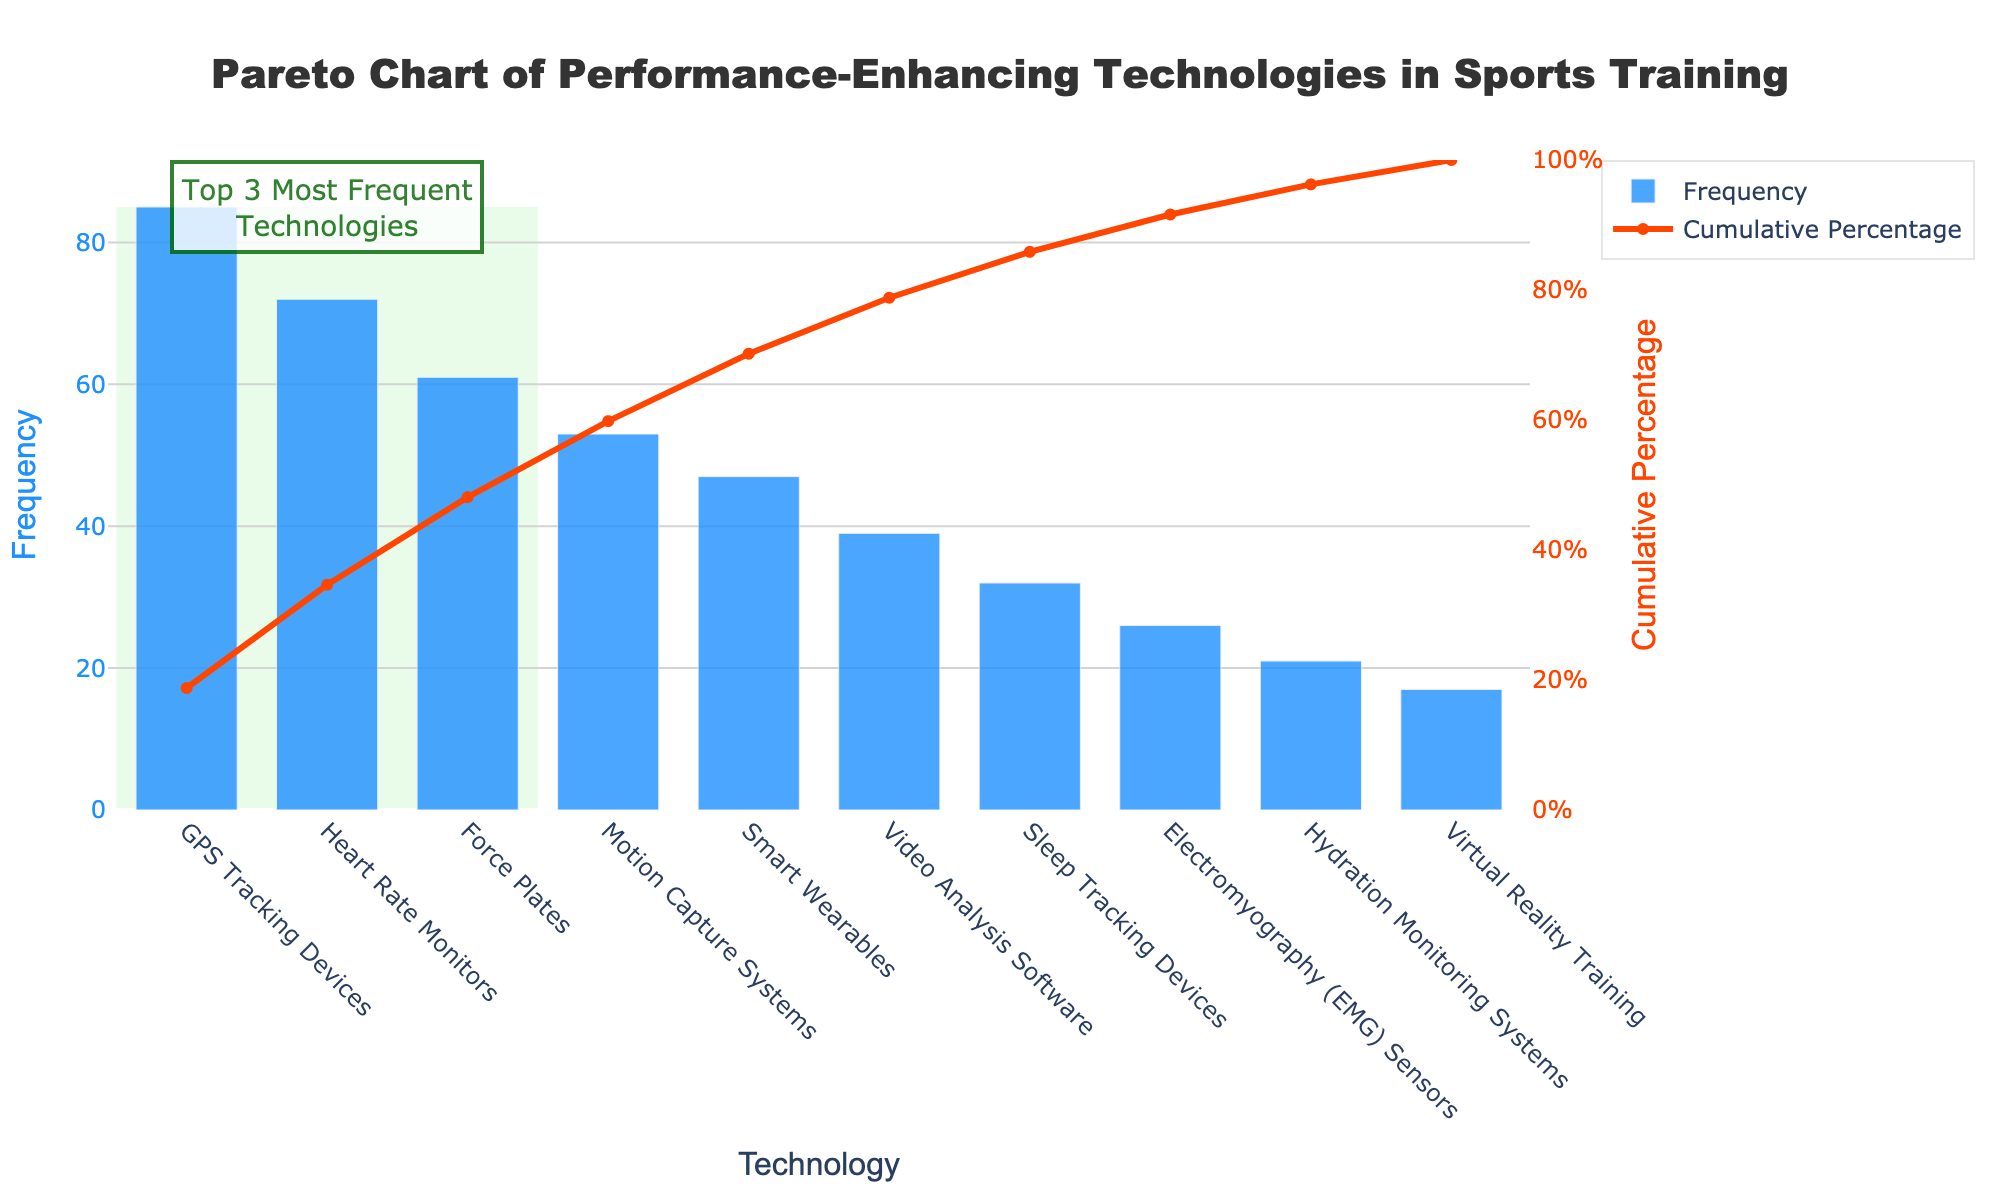How many technologies are represented in the chart? The x-axis of the chart contains labels for each technology. By counting the labels along the x-axis, we can determine the number of technologies represented. The x-axis shows 10 different technologies.
Answer: 10 Which technology has the highest frequency of use? By examining the heights of the blue bars representing the frequency of use, we can identify the tallest bar. The tallest bar corresponds to GPS Tracking Devices with a frequency of 85.
Answer: GPS Tracking Devices What's the total frequency of the top three technologies? From the chart, the top three technologies are GPS Tracking Devices (85), Heart Rate Monitors (72), and Force Plates (61). Adding these values together gives: 85 + 72 + 61 = 218.
Answer: 218 At what frequency level does the cumulative percentage line cross 50%? The line graph representing the cumulative percentage intersects the 50% mark between Heart Rate Monitors and Force Plates. Observing the x-axis, we see this happens around the frequency of Heart Rate Monitors, which is 72.
Answer: 72 What's the cumulative percentage after including the first four technologies? The cumulative percentages for the first four technologies are listed in the chart as follows: GPS Tracking Devices (85), Heart Rate Monitors (72), Force Plates (61), and Motion Capture Systems (53). Summing their frequencies gives: 85 + 72 + 61 + 53 = 271. The total frequency for all technologies is 453. (271/453) * 100 = 59.8%.
Answer: 59.8% Which technology is highlighted by the green rectangle? The green rectangle on the chart highlights the top three most frequent technologies. These are GPS Tracking Devices, Heart Rate Monitors, and Force Plates.
Answer: GPS Tracking Devices, Heart Rate Monitors, Force Plates Which technology has the lowest frequency of use? By identifying the shortest blue bar in the chart, we see that Virtual Reality Training has the lowest frequency of use, at 17.
Answer: Virtual Reality Training How does the frequency of Smart Wearables compare to Motion Capture Systems? From the chart, Smart Wearables have a frequency of 47 and Motion Capture Systems have a frequency of 53. Thus, Smart Wearables are used less frequently than Motion Capture Systems.
Answer: Less What's the cumulative percentage after adding Smart Wearables? The cumulative frequency after Smart Wearables includes the first five technologies: GPS Tracking Devices (85), Heart Rate Monitors (72), Force Plates (61), Motion Capture Systems (53), and Smart Wearables (47). Adding these: 85 + 72 + 61 + 53 + 47 = 318. (318/453) * 100 = 70.2%.
Answer: 70.2% Which technology appears fifth in the ranking by frequency? By observing the order of the bars based on their heights, Smart Wearables appear as the fifth technology.
Answer: Smart Wearables 